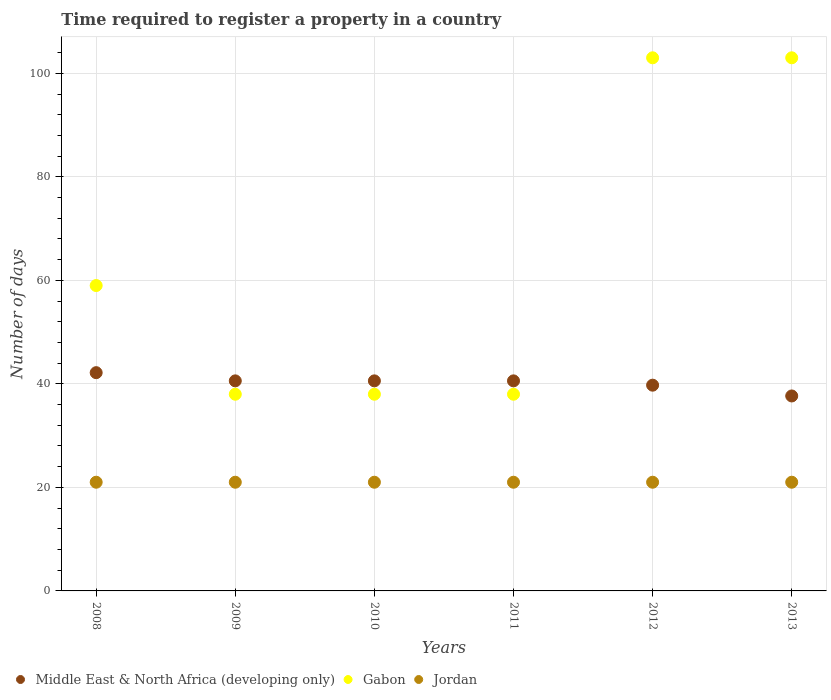How many different coloured dotlines are there?
Your answer should be compact. 3. Is the number of dotlines equal to the number of legend labels?
Your answer should be very brief. Yes. What is the number of days required to register a property in Jordan in 2012?
Your answer should be very brief. 21. Across all years, what is the maximum number of days required to register a property in Gabon?
Make the answer very short. 103. What is the total number of days required to register a property in Middle East & North Africa (developing only) in the graph?
Make the answer very short. 241.33. What is the difference between the number of days required to register a property in Gabon in 2008 and that in 2010?
Provide a short and direct response. 21. What is the difference between the number of days required to register a property in Jordan in 2009 and the number of days required to register a property in Middle East & North Africa (developing only) in 2012?
Keep it short and to the point. -18.75. What is the average number of days required to register a property in Middle East & North Africa (developing only) per year?
Offer a very short reply. 40.22. In the year 2013, what is the difference between the number of days required to register a property in Middle East & North Africa (developing only) and number of days required to register a property in Jordan?
Ensure brevity in your answer.  16.67. In how many years, is the number of days required to register a property in Jordan greater than 76 days?
Provide a short and direct response. 0. What is the ratio of the number of days required to register a property in Middle East & North Africa (developing only) in 2009 to that in 2010?
Provide a short and direct response. 1. Is the number of days required to register a property in Jordan in 2009 less than that in 2012?
Offer a very short reply. No. Is the difference between the number of days required to register a property in Middle East & North Africa (developing only) in 2008 and 2012 greater than the difference between the number of days required to register a property in Jordan in 2008 and 2012?
Offer a terse response. Yes. Is the number of days required to register a property in Jordan strictly less than the number of days required to register a property in Gabon over the years?
Provide a succinct answer. Yes. Does the graph contain grids?
Provide a succinct answer. Yes. How are the legend labels stacked?
Make the answer very short. Horizontal. What is the title of the graph?
Ensure brevity in your answer.  Time required to register a property in a country. What is the label or title of the Y-axis?
Give a very brief answer. Number of days. What is the Number of days of Middle East & North Africa (developing only) in 2008?
Your answer should be very brief. 42.17. What is the Number of days of Gabon in 2008?
Provide a short and direct response. 59. What is the Number of days of Jordan in 2008?
Offer a terse response. 21. What is the Number of days of Middle East & North Africa (developing only) in 2009?
Your response must be concise. 40.58. What is the Number of days in Gabon in 2009?
Ensure brevity in your answer.  38. What is the Number of days in Jordan in 2009?
Give a very brief answer. 21. What is the Number of days in Middle East & North Africa (developing only) in 2010?
Give a very brief answer. 40.58. What is the Number of days of Middle East & North Africa (developing only) in 2011?
Ensure brevity in your answer.  40.58. What is the Number of days of Middle East & North Africa (developing only) in 2012?
Your answer should be very brief. 39.75. What is the Number of days of Gabon in 2012?
Your response must be concise. 103. What is the Number of days in Jordan in 2012?
Your answer should be compact. 21. What is the Number of days in Middle East & North Africa (developing only) in 2013?
Your response must be concise. 37.67. What is the Number of days in Gabon in 2013?
Offer a very short reply. 103. Across all years, what is the maximum Number of days of Middle East & North Africa (developing only)?
Ensure brevity in your answer.  42.17. Across all years, what is the maximum Number of days of Gabon?
Your response must be concise. 103. Across all years, what is the maximum Number of days in Jordan?
Offer a terse response. 21. Across all years, what is the minimum Number of days in Middle East & North Africa (developing only)?
Give a very brief answer. 37.67. Across all years, what is the minimum Number of days of Gabon?
Offer a very short reply. 38. Across all years, what is the minimum Number of days in Jordan?
Provide a succinct answer. 21. What is the total Number of days of Middle East & North Africa (developing only) in the graph?
Your answer should be compact. 241.33. What is the total Number of days of Gabon in the graph?
Your answer should be compact. 379. What is the total Number of days in Jordan in the graph?
Give a very brief answer. 126. What is the difference between the Number of days in Middle East & North Africa (developing only) in 2008 and that in 2009?
Provide a short and direct response. 1.58. What is the difference between the Number of days in Middle East & North Africa (developing only) in 2008 and that in 2010?
Keep it short and to the point. 1.58. What is the difference between the Number of days of Gabon in 2008 and that in 2010?
Your answer should be very brief. 21. What is the difference between the Number of days in Middle East & North Africa (developing only) in 2008 and that in 2011?
Your answer should be compact. 1.58. What is the difference between the Number of days in Gabon in 2008 and that in 2011?
Give a very brief answer. 21. What is the difference between the Number of days in Middle East & North Africa (developing only) in 2008 and that in 2012?
Your response must be concise. 2.42. What is the difference between the Number of days in Gabon in 2008 and that in 2012?
Offer a very short reply. -44. What is the difference between the Number of days of Jordan in 2008 and that in 2012?
Offer a very short reply. 0. What is the difference between the Number of days in Gabon in 2008 and that in 2013?
Provide a short and direct response. -44. What is the difference between the Number of days in Jordan in 2008 and that in 2013?
Keep it short and to the point. 0. What is the difference between the Number of days in Gabon in 2009 and that in 2010?
Keep it short and to the point. 0. What is the difference between the Number of days of Jordan in 2009 and that in 2010?
Give a very brief answer. 0. What is the difference between the Number of days of Middle East & North Africa (developing only) in 2009 and that in 2011?
Keep it short and to the point. 0. What is the difference between the Number of days in Gabon in 2009 and that in 2012?
Your answer should be very brief. -65. What is the difference between the Number of days of Middle East & North Africa (developing only) in 2009 and that in 2013?
Your response must be concise. 2.92. What is the difference between the Number of days of Gabon in 2009 and that in 2013?
Your answer should be compact. -65. What is the difference between the Number of days of Middle East & North Africa (developing only) in 2010 and that in 2011?
Your response must be concise. 0. What is the difference between the Number of days in Middle East & North Africa (developing only) in 2010 and that in 2012?
Provide a succinct answer. 0.83. What is the difference between the Number of days in Gabon in 2010 and that in 2012?
Offer a terse response. -65. What is the difference between the Number of days of Middle East & North Africa (developing only) in 2010 and that in 2013?
Provide a succinct answer. 2.92. What is the difference between the Number of days in Gabon in 2010 and that in 2013?
Your answer should be very brief. -65. What is the difference between the Number of days of Gabon in 2011 and that in 2012?
Your response must be concise. -65. What is the difference between the Number of days of Middle East & North Africa (developing only) in 2011 and that in 2013?
Your answer should be very brief. 2.92. What is the difference between the Number of days of Gabon in 2011 and that in 2013?
Your answer should be very brief. -65. What is the difference between the Number of days of Middle East & North Africa (developing only) in 2012 and that in 2013?
Provide a succinct answer. 2.08. What is the difference between the Number of days of Gabon in 2012 and that in 2013?
Make the answer very short. 0. What is the difference between the Number of days in Middle East & North Africa (developing only) in 2008 and the Number of days in Gabon in 2009?
Make the answer very short. 4.17. What is the difference between the Number of days in Middle East & North Africa (developing only) in 2008 and the Number of days in Jordan in 2009?
Your answer should be very brief. 21.17. What is the difference between the Number of days of Gabon in 2008 and the Number of days of Jordan in 2009?
Ensure brevity in your answer.  38. What is the difference between the Number of days in Middle East & North Africa (developing only) in 2008 and the Number of days in Gabon in 2010?
Offer a very short reply. 4.17. What is the difference between the Number of days in Middle East & North Africa (developing only) in 2008 and the Number of days in Jordan in 2010?
Keep it short and to the point. 21.17. What is the difference between the Number of days of Gabon in 2008 and the Number of days of Jordan in 2010?
Make the answer very short. 38. What is the difference between the Number of days of Middle East & North Africa (developing only) in 2008 and the Number of days of Gabon in 2011?
Your response must be concise. 4.17. What is the difference between the Number of days of Middle East & North Africa (developing only) in 2008 and the Number of days of Jordan in 2011?
Offer a very short reply. 21.17. What is the difference between the Number of days in Middle East & North Africa (developing only) in 2008 and the Number of days in Gabon in 2012?
Offer a very short reply. -60.83. What is the difference between the Number of days of Middle East & North Africa (developing only) in 2008 and the Number of days of Jordan in 2012?
Your answer should be compact. 21.17. What is the difference between the Number of days of Middle East & North Africa (developing only) in 2008 and the Number of days of Gabon in 2013?
Provide a succinct answer. -60.83. What is the difference between the Number of days in Middle East & North Africa (developing only) in 2008 and the Number of days in Jordan in 2013?
Your answer should be compact. 21.17. What is the difference between the Number of days of Middle East & North Africa (developing only) in 2009 and the Number of days of Gabon in 2010?
Your answer should be compact. 2.58. What is the difference between the Number of days of Middle East & North Africa (developing only) in 2009 and the Number of days of Jordan in 2010?
Offer a very short reply. 19.58. What is the difference between the Number of days of Middle East & North Africa (developing only) in 2009 and the Number of days of Gabon in 2011?
Offer a terse response. 2.58. What is the difference between the Number of days in Middle East & North Africa (developing only) in 2009 and the Number of days in Jordan in 2011?
Your answer should be compact. 19.58. What is the difference between the Number of days of Middle East & North Africa (developing only) in 2009 and the Number of days of Gabon in 2012?
Your answer should be compact. -62.42. What is the difference between the Number of days in Middle East & North Africa (developing only) in 2009 and the Number of days in Jordan in 2012?
Provide a short and direct response. 19.58. What is the difference between the Number of days of Middle East & North Africa (developing only) in 2009 and the Number of days of Gabon in 2013?
Offer a terse response. -62.42. What is the difference between the Number of days of Middle East & North Africa (developing only) in 2009 and the Number of days of Jordan in 2013?
Your answer should be compact. 19.58. What is the difference between the Number of days of Gabon in 2009 and the Number of days of Jordan in 2013?
Give a very brief answer. 17. What is the difference between the Number of days of Middle East & North Africa (developing only) in 2010 and the Number of days of Gabon in 2011?
Make the answer very short. 2.58. What is the difference between the Number of days in Middle East & North Africa (developing only) in 2010 and the Number of days in Jordan in 2011?
Your response must be concise. 19.58. What is the difference between the Number of days in Middle East & North Africa (developing only) in 2010 and the Number of days in Gabon in 2012?
Your response must be concise. -62.42. What is the difference between the Number of days in Middle East & North Africa (developing only) in 2010 and the Number of days in Jordan in 2012?
Give a very brief answer. 19.58. What is the difference between the Number of days in Gabon in 2010 and the Number of days in Jordan in 2012?
Keep it short and to the point. 17. What is the difference between the Number of days of Middle East & North Africa (developing only) in 2010 and the Number of days of Gabon in 2013?
Provide a succinct answer. -62.42. What is the difference between the Number of days of Middle East & North Africa (developing only) in 2010 and the Number of days of Jordan in 2013?
Keep it short and to the point. 19.58. What is the difference between the Number of days of Gabon in 2010 and the Number of days of Jordan in 2013?
Keep it short and to the point. 17. What is the difference between the Number of days in Middle East & North Africa (developing only) in 2011 and the Number of days in Gabon in 2012?
Make the answer very short. -62.42. What is the difference between the Number of days of Middle East & North Africa (developing only) in 2011 and the Number of days of Jordan in 2012?
Ensure brevity in your answer.  19.58. What is the difference between the Number of days in Gabon in 2011 and the Number of days in Jordan in 2012?
Offer a very short reply. 17. What is the difference between the Number of days of Middle East & North Africa (developing only) in 2011 and the Number of days of Gabon in 2013?
Provide a succinct answer. -62.42. What is the difference between the Number of days in Middle East & North Africa (developing only) in 2011 and the Number of days in Jordan in 2013?
Your answer should be very brief. 19.58. What is the difference between the Number of days in Gabon in 2011 and the Number of days in Jordan in 2013?
Your answer should be compact. 17. What is the difference between the Number of days in Middle East & North Africa (developing only) in 2012 and the Number of days in Gabon in 2013?
Keep it short and to the point. -63.25. What is the difference between the Number of days of Middle East & North Africa (developing only) in 2012 and the Number of days of Jordan in 2013?
Keep it short and to the point. 18.75. What is the difference between the Number of days of Gabon in 2012 and the Number of days of Jordan in 2013?
Offer a terse response. 82. What is the average Number of days of Middle East & North Africa (developing only) per year?
Your answer should be compact. 40.22. What is the average Number of days of Gabon per year?
Provide a short and direct response. 63.17. In the year 2008, what is the difference between the Number of days of Middle East & North Africa (developing only) and Number of days of Gabon?
Your answer should be compact. -16.83. In the year 2008, what is the difference between the Number of days of Middle East & North Africa (developing only) and Number of days of Jordan?
Make the answer very short. 21.17. In the year 2008, what is the difference between the Number of days of Gabon and Number of days of Jordan?
Your answer should be very brief. 38. In the year 2009, what is the difference between the Number of days of Middle East & North Africa (developing only) and Number of days of Gabon?
Offer a very short reply. 2.58. In the year 2009, what is the difference between the Number of days in Middle East & North Africa (developing only) and Number of days in Jordan?
Give a very brief answer. 19.58. In the year 2009, what is the difference between the Number of days of Gabon and Number of days of Jordan?
Provide a short and direct response. 17. In the year 2010, what is the difference between the Number of days in Middle East & North Africa (developing only) and Number of days in Gabon?
Keep it short and to the point. 2.58. In the year 2010, what is the difference between the Number of days in Middle East & North Africa (developing only) and Number of days in Jordan?
Offer a terse response. 19.58. In the year 2011, what is the difference between the Number of days in Middle East & North Africa (developing only) and Number of days in Gabon?
Provide a succinct answer. 2.58. In the year 2011, what is the difference between the Number of days of Middle East & North Africa (developing only) and Number of days of Jordan?
Keep it short and to the point. 19.58. In the year 2012, what is the difference between the Number of days of Middle East & North Africa (developing only) and Number of days of Gabon?
Make the answer very short. -63.25. In the year 2012, what is the difference between the Number of days of Middle East & North Africa (developing only) and Number of days of Jordan?
Offer a terse response. 18.75. In the year 2012, what is the difference between the Number of days of Gabon and Number of days of Jordan?
Make the answer very short. 82. In the year 2013, what is the difference between the Number of days in Middle East & North Africa (developing only) and Number of days in Gabon?
Give a very brief answer. -65.33. In the year 2013, what is the difference between the Number of days of Middle East & North Africa (developing only) and Number of days of Jordan?
Give a very brief answer. 16.67. In the year 2013, what is the difference between the Number of days of Gabon and Number of days of Jordan?
Offer a very short reply. 82. What is the ratio of the Number of days of Middle East & North Africa (developing only) in 2008 to that in 2009?
Make the answer very short. 1.04. What is the ratio of the Number of days in Gabon in 2008 to that in 2009?
Your answer should be compact. 1.55. What is the ratio of the Number of days of Middle East & North Africa (developing only) in 2008 to that in 2010?
Your answer should be very brief. 1.04. What is the ratio of the Number of days of Gabon in 2008 to that in 2010?
Keep it short and to the point. 1.55. What is the ratio of the Number of days in Jordan in 2008 to that in 2010?
Offer a terse response. 1. What is the ratio of the Number of days in Middle East & North Africa (developing only) in 2008 to that in 2011?
Give a very brief answer. 1.04. What is the ratio of the Number of days in Gabon in 2008 to that in 2011?
Provide a succinct answer. 1.55. What is the ratio of the Number of days of Middle East & North Africa (developing only) in 2008 to that in 2012?
Provide a short and direct response. 1.06. What is the ratio of the Number of days in Gabon in 2008 to that in 2012?
Keep it short and to the point. 0.57. What is the ratio of the Number of days in Middle East & North Africa (developing only) in 2008 to that in 2013?
Your response must be concise. 1.12. What is the ratio of the Number of days in Gabon in 2008 to that in 2013?
Your answer should be very brief. 0.57. What is the ratio of the Number of days of Middle East & North Africa (developing only) in 2009 to that in 2010?
Keep it short and to the point. 1. What is the ratio of the Number of days in Gabon in 2009 to that in 2010?
Your response must be concise. 1. What is the ratio of the Number of days of Jordan in 2009 to that in 2010?
Offer a terse response. 1. What is the ratio of the Number of days of Jordan in 2009 to that in 2011?
Provide a succinct answer. 1. What is the ratio of the Number of days in Middle East & North Africa (developing only) in 2009 to that in 2012?
Give a very brief answer. 1.02. What is the ratio of the Number of days in Gabon in 2009 to that in 2012?
Your answer should be compact. 0.37. What is the ratio of the Number of days of Middle East & North Africa (developing only) in 2009 to that in 2013?
Provide a succinct answer. 1.08. What is the ratio of the Number of days in Gabon in 2009 to that in 2013?
Your answer should be very brief. 0.37. What is the ratio of the Number of days in Gabon in 2010 to that in 2012?
Provide a succinct answer. 0.37. What is the ratio of the Number of days in Jordan in 2010 to that in 2012?
Keep it short and to the point. 1. What is the ratio of the Number of days in Middle East & North Africa (developing only) in 2010 to that in 2013?
Provide a succinct answer. 1.08. What is the ratio of the Number of days of Gabon in 2010 to that in 2013?
Your answer should be compact. 0.37. What is the ratio of the Number of days in Jordan in 2010 to that in 2013?
Make the answer very short. 1. What is the ratio of the Number of days in Gabon in 2011 to that in 2012?
Provide a succinct answer. 0.37. What is the ratio of the Number of days in Middle East & North Africa (developing only) in 2011 to that in 2013?
Provide a short and direct response. 1.08. What is the ratio of the Number of days of Gabon in 2011 to that in 2013?
Provide a succinct answer. 0.37. What is the ratio of the Number of days of Middle East & North Africa (developing only) in 2012 to that in 2013?
Give a very brief answer. 1.06. What is the difference between the highest and the second highest Number of days in Middle East & North Africa (developing only)?
Your answer should be very brief. 1.58. What is the difference between the highest and the second highest Number of days of Gabon?
Your response must be concise. 0. What is the difference between the highest and the lowest Number of days of Middle East & North Africa (developing only)?
Offer a terse response. 4.5. What is the difference between the highest and the lowest Number of days in Gabon?
Your answer should be very brief. 65. 